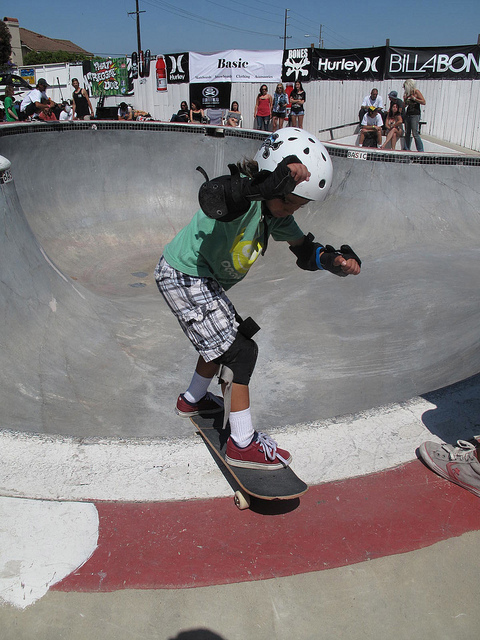Please transcribe the text information in this image. Basic BONES Hurley BILLABON Hurley 